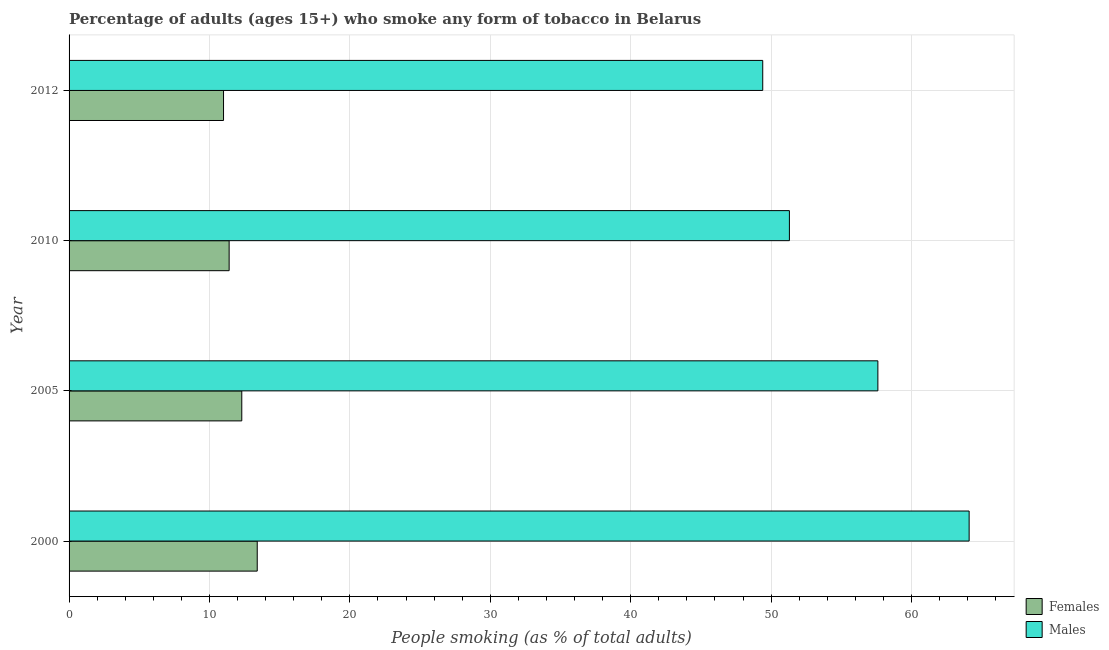How many different coloured bars are there?
Your response must be concise. 2. How many groups of bars are there?
Your answer should be compact. 4. Are the number of bars per tick equal to the number of legend labels?
Give a very brief answer. Yes. How many bars are there on the 2nd tick from the top?
Your answer should be very brief. 2. What is the label of the 2nd group of bars from the top?
Provide a short and direct response. 2010. What is the percentage of females who smoke in 2012?
Your response must be concise. 11. Across all years, what is the maximum percentage of males who smoke?
Your answer should be very brief. 64.1. Across all years, what is the minimum percentage of males who smoke?
Provide a short and direct response. 49.4. What is the total percentage of females who smoke in the graph?
Your answer should be very brief. 48.1. What is the difference between the percentage of males who smoke in 2005 and the percentage of females who smoke in 2012?
Ensure brevity in your answer.  46.6. What is the average percentage of males who smoke per year?
Make the answer very short. 55.6. In the year 2012, what is the difference between the percentage of females who smoke and percentage of males who smoke?
Offer a very short reply. -38.4. In how many years, is the percentage of females who smoke greater than 8 %?
Your answer should be compact. 4. What is the ratio of the percentage of females who smoke in 2000 to that in 2005?
Offer a very short reply. 1.09. What is the difference between the highest and the lowest percentage of females who smoke?
Your answer should be very brief. 2.4. In how many years, is the percentage of males who smoke greater than the average percentage of males who smoke taken over all years?
Your answer should be very brief. 2. Is the sum of the percentage of males who smoke in 2000 and 2005 greater than the maximum percentage of females who smoke across all years?
Your answer should be very brief. Yes. What does the 1st bar from the top in 2010 represents?
Offer a terse response. Males. What does the 1st bar from the bottom in 2000 represents?
Provide a succinct answer. Females. How many bars are there?
Keep it short and to the point. 8. How many years are there in the graph?
Your response must be concise. 4. What is the difference between two consecutive major ticks on the X-axis?
Your answer should be very brief. 10. Are the values on the major ticks of X-axis written in scientific E-notation?
Offer a very short reply. No. Does the graph contain any zero values?
Your response must be concise. No. Does the graph contain grids?
Your answer should be compact. Yes. How many legend labels are there?
Your answer should be compact. 2. What is the title of the graph?
Provide a succinct answer. Percentage of adults (ages 15+) who smoke any form of tobacco in Belarus. What is the label or title of the X-axis?
Make the answer very short. People smoking (as % of total adults). What is the label or title of the Y-axis?
Make the answer very short. Year. What is the People smoking (as % of total adults) in Males in 2000?
Keep it short and to the point. 64.1. What is the People smoking (as % of total adults) in Males in 2005?
Your response must be concise. 57.6. What is the People smoking (as % of total adults) in Males in 2010?
Your answer should be very brief. 51.3. What is the People smoking (as % of total adults) in Females in 2012?
Make the answer very short. 11. What is the People smoking (as % of total adults) of Males in 2012?
Your answer should be very brief. 49.4. Across all years, what is the maximum People smoking (as % of total adults) of Males?
Provide a succinct answer. 64.1. Across all years, what is the minimum People smoking (as % of total adults) in Females?
Provide a short and direct response. 11. Across all years, what is the minimum People smoking (as % of total adults) of Males?
Your answer should be compact. 49.4. What is the total People smoking (as % of total adults) in Females in the graph?
Give a very brief answer. 48.1. What is the total People smoking (as % of total adults) in Males in the graph?
Your answer should be compact. 222.4. What is the difference between the People smoking (as % of total adults) of Females in 2000 and that in 2005?
Provide a short and direct response. 1.1. What is the difference between the People smoking (as % of total adults) of Males in 2005 and that in 2010?
Your answer should be compact. 6.3. What is the difference between the People smoking (as % of total adults) in Males in 2005 and that in 2012?
Provide a short and direct response. 8.2. What is the difference between the People smoking (as % of total adults) in Males in 2010 and that in 2012?
Give a very brief answer. 1.9. What is the difference between the People smoking (as % of total adults) of Females in 2000 and the People smoking (as % of total adults) of Males in 2005?
Offer a terse response. -44.2. What is the difference between the People smoking (as % of total adults) of Females in 2000 and the People smoking (as % of total adults) of Males in 2010?
Keep it short and to the point. -37.9. What is the difference between the People smoking (as % of total adults) in Females in 2000 and the People smoking (as % of total adults) in Males in 2012?
Keep it short and to the point. -36. What is the difference between the People smoking (as % of total adults) of Females in 2005 and the People smoking (as % of total adults) of Males in 2010?
Your answer should be compact. -39. What is the difference between the People smoking (as % of total adults) in Females in 2005 and the People smoking (as % of total adults) in Males in 2012?
Offer a terse response. -37.1. What is the difference between the People smoking (as % of total adults) of Females in 2010 and the People smoking (as % of total adults) of Males in 2012?
Your answer should be compact. -38. What is the average People smoking (as % of total adults) in Females per year?
Provide a succinct answer. 12.03. What is the average People smoking (as % of total adults) of Males per year?
Your answer should be very brief. 55.6. In the year 2000, what is the difference between the People smoking (as % of total adults) of Females and People smoking (as % of total adults) of Males?
Ensure brevity in your answer.  -50.7. In the year 2005, what is the difference between the People smoking (as % of total adults) of Females and People smoking (as % of total adults) of Males?
Ensure brevity in your answer.  -45.3. In the year 2010, what is the difference between the People smoking (as % of total adults) of Females and People smoking (as % of total adults) of Males?
Provide a short and direct response. -39.9. In the year 2012, what is the difference between the People smoking (as % of total adults) in Females and People smoking (as % of total adults) in Males?
Give a very brief answer. -38.4. What is the ratio of the People smoking (as % of total adults) in Females in 2000 to that in 2005?
Keep it short and to the point. 1.09. What is the ratio of the People smoking (as % of total adults) in Males in 2000 to that in 2005?
Provide a short and direct response. 1.11. What is the ratio of the People smoking (as % of total adults) in Females in 2000 to that in 2010?
Provide a short and direct response. 1.18. What is the ratio of the People smoking (as % of total adults) in Males in 2000 to that in 2010?
Offer a very short reply. 1.25. What is the ratio of the People smoking (as % of total adults) in Females in 2000 to that in 2012?
Offer a terse response. 1.22. What is the ratio of the People smoking (as % of total adults) in Males in 2000 to that in 2012?
Provide a succinct answer. 1.3. What is the ratio of the People smoking (as % of total adults) in Females in 2005 to that in 2010?
Provide a succinct answer. 1.08. What is the ratio of the People smoking (as % of total adults) in Males in 2005 to that in 2010?
Offer a very short reply. 1.12. What is the ratio of the People smoking (as % of total adults) of Females in 2005 to that in 2012?
Offer a very short reply. 1.12. What is the ratio of the People smoking (as % of total adults) of Males in 2005 to that in 2012?
Your response must be concise. 1.17. What is the ratio of the People smoking (as % of total adults) in Females in 2010 to that in 2012?
Offer a very short reply. 1.04. What is the ratio of the People smoking (as % of total adults) of Males in 2010 to that in 2012?
Provide a succinct answer. 1.04. What is the difference between the highest and the second highest People smoking (as % of total adults) in Females?
Your answer should be very brief. 1.1. What is the difference between the highest and the second highest People smoking (as % of total adults) in Males?
Your answer should be compact. 6.5. What is the difference between the highest and the lowest People smoking (as % of total adults) in Males?
Offer a terse response. 14.7. 